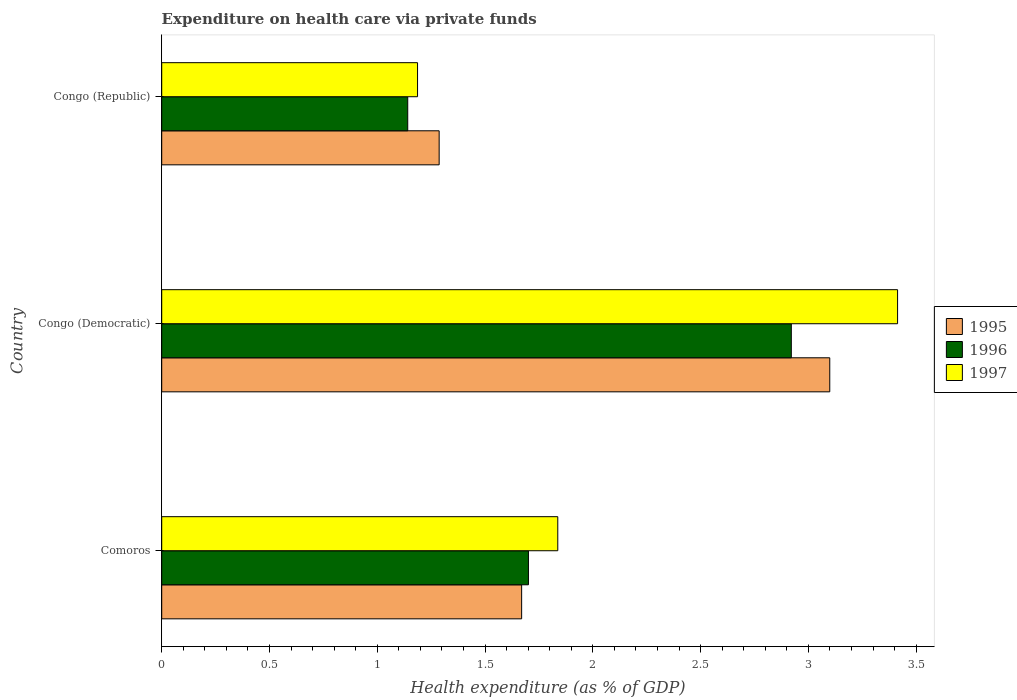How many different coloured bars are there?
Offer a very short reply. 3. How many groups of bars are there?
Offer a terse response. 3. How many bars are there on the 1st tick from the top?
Ensure brevity in your answer.  3. What is the label of the 1st group of bars from the top?
Your response must be concise. Congo (Republic). What is the expenditure made on health care in 1996 in Comoros?
Your response must be concise. 1.7. Across all countries, what is the maximum expenditure made on health care in 1996?
Your answer should be very brief. 2.92. Across all countries, what is the minimum expenditure made on health care in 1997?
Your answer should be very brief. 1.19. In which country was the expenditure made on health care in 1997 maximum?
Provide a succinct answer. Congo (Democratic). In which country was the expenditure made on health care in 1997 minimum?
Give a very brief answer. Congo (Republic). What is the total expenditure made on health care in 1997 in the graph?
Provide a succinct answer. 6.44. What is the difference between the expenditure made on health care in 1997 in Comoros and that in Congo (Republic)?
Make the answer very short. 0.65. What is the difference between the expenditure made on health care in 1995 in Comoros and the expenditure made on health care in 1996 in Congo (Republic)?
Your answer should be compact. 0.53. What is the average expenditure made on health care in 1996 per country?
Your answer should be compact. 1.92. What is the difference between the expenditure made on health care in 1997 and expenditure made on health care in 1996 in Congo (Democratic)?
Your response must be concise. 0.49. What is the ratio of the expenditure made on health care in 1996 in Comoros to that in Congo (Republic)?
Make the answer very short. 1.49. Is the expenditure made on health care in 1996 in Comoros less than that in Congo (Republic)?
Give a very brief answer. No. Is the difference between the expenditure made on health care in 1997 in Comoros and Congo (Republic) greater than the difference between the expenditure made on health care in 1996 in Comoros and Congo (Republic)?
Provide a succinct answer. Yes. What is the difference between the highest and the second highest expenditure made on health care in 1996?
Ensure brevity in your answer.  1.22. What is the difference between the highest and the lowest expenditure made on health care in 1997?
Your answer should be compact. 2.23. Is the sum of the expenditure made on health care in 1995 in Comoros and Congo (Republic) greater than the maximum expenditure made on health care in 1997 across all countries?
Your answer should be compact. No. What does the 2nd bar from the top in Congo (Democratic) represents?
Provide a succinct answer. 1996. How many bars are there?
Keep it short and to the point. 9. Are all the bars in the graph horizontal?
Ensure brevity in your answer.  Yes. How many countries are there in the graph?
Your response must be concise. 3. Are the values on the major ticks of X-axis written in scientific E-notation?
Provide a short and direct response. No. Does the graph contain grids?
Keep it short and to the point. No. How many legend labels are there?
Provide a short and direct response. 3. How are the legend labels stacked?
Your answer should be compact. Vertical. What is the title of the graph?
Give a very brief answer. Expenditure on health care via private funds. Does "1968" appear as one of the legend labels in the graph?
Offer a terse response. No. What is the label or title of the X-axis?
Offer a terse response. Health expenditure (as % of GDP). What is the Health expenditure (as % of GDP) in 1995 in Comoros?
Keep it short and to the point. 1.67. What is the Health expenditure (as % of GDP) in 1996 in Comoros?
Offer a terse response. 1.7. What is the Health expenditure (as % of GDP) in 1997 in Comoros?
Your answer should be very brief. 1.84. What is the Health expenditure (as % of GDP) in 1995 in Congo (Democratic)?
Offer a terse response. 3.1. What is the Health expenditure (as % of GDP) in 1996 in Congo (Democratic)?
Keep it short and to the point. 2.92. What is the Health expenditure (as % of GDP) of 1997 in Congo (Democratic)?
Your answer should be very brief. 3.41. What is the Health expenditure (as % of GDP) of 1995 in Congo (Republic)?
Provide a succinct answer. 1.29. What is the Health expenditure (as % of GDP) in 1996 in Congo (Republic)?
Offer a very short reply. 1.14. What is the Health expenditure (as % of GDP) of 1997 in Congo (Republic)?
Make the answer very short. 1.19. Across all countries, what is the maximum Health expenditure (as % of GDP) of 1995?
Offer a very short reply. 3.1. Across all countries, what is the maximum Health expenditure (as % of GDP) in 1996?
Your answer should be very brief. 2.92. Across all countries, what is the maximum Health expenditure (as % of GDP) in 1997?
Your response must be concise. 3.41. Across all countries, what is the minimum Health expenditure (as % of GDP) in 1995?
Provide a short and direct response. 1.29. Across all countries, what is the minimum Health expenditure (as % of GDP) of 1996?
Offer a terse response. 1.14. Across all countries, what is the minimum Health expenditure (as % of GDP) in 1997?
Your answer should be very brief. 1.19. What is the total Health expenditure (as % of GDP) of 1995 in the graph?
Ensure brevity in your answer.  6.06. What is the total Health expenditure (as % of GDP) of 1996 in the graph?
Your response must be concise. 5.76. What is the total Health expenditure (as % of GDP) of 1997 in the graph?
Your answer should be compact. 6.44. What is the difference between the Health expenditure (as % of GDP) of 1995 in Comoros and that in Congo (Democratic)?
Offer a terse response. -1.43. What is the difference between the Health expenditure (as % of GDP) in 1996 in Comoros and that in Congo (Democratic)?
Keep it short and to the point. -1.22. What is the difference between the Health expenditure (as % of GDP) in 1997 in Comoros and that in Congo (Democratic)?
Keep it short and to the point. -1.58. What is the difference between the Health expenditure (as % of GDP) of 1995 in Comoros and that in Congo (Republic)?
Provide a succinct answer. 0.38. What is the difference between the Health expenditure (as % of GDP) in 1996 in Comoros and that in Congo (Republic)?
Your response must be concise. 0.56. What is the difference between the Health expenditure (as % of GDP) in 1997 in Comoros and that in Congo (Republic)?
Provide a succinct answer. 0.65. What is the difference between the Health expenditure (as % of GDP) in 1995 in Congo (Democratic) and that in Congo (Republic)?
Your answer should be compact. 1.81. What is the difference between the Health expenditure (as % of GDP) of 1996 in Congo (Democratic) and that in Congo (Republic)?
Your response must be concise. 1.78. What is the difference between the Health expenditure (as % of GDP) in 1997 in Congo (Democratic) and that in Congo (Republic)?
Make the answer very short. 2.23. What is the difference between the Health expenditure (as % of GDP) of 1995 in Comoros and the Health expenditure (as % of GDP) of 1996 in Congo (Democratic)?
Keep it short and to the point. -1.25. What is the difference between the Health expenditure (as % of GDP) in 1995 in Comoros and the Health expenditure (as % of GDP) in 1997 in Congo (Democratic)?
Your answer should be very brief. -1.74. What is the difference between the Health expenditure (as % of GDP) of 1996 in Comoros and the Health expenditure (as % of GDP) of 1997 in Congo (Democratic)?
Offer a terse response. -1.71. What is the difference between the Health expenditure (as % of GDP) in 1995 in Comoros and the Health expenditure (as % of GDP) in 1996 in Congo (Republic)?
Your answer should be compact. 0.53. What is the difference between the Health expenditure (as % of GDP) in 1995 in Comoros and the Health expenditure (as % of GDP) in 1997 in Congo (Republic)?
Make the answer very short. 0.48. What is the difference between the Health expenditure (as % of GDP) of 1996 in Comoros and the Health expenditure (as % of GDP) of 1997 in Congo (Republic)?
Make the answer very short. 0.51. What is the difference between the Health expenditure (as % of GDP) in 1995 in Congo (Democratic) and the Health expenditure (as % of GDP) in 1996 in Congo (Republic)?
Keep it short and to the point. 1.96. What is the difference between the Health expenditure (as % of GDP) of 1995 in Congo (Democratic) and the Health expenditure (as % of GDP) of 1997 in Congo (Republic)?
Give a very brief answer. 1.91. What is the difference between the Health expenditure (as % of GDP) in 1996 in Congo (Democratic) and the Health expenditure (as % of GDP) in 1997 in Congo (Republic)?
Your answer should be very brief. 1.73. What is the average Health expenditure (as % of GDP) in 1995 per country?
Offer a very short reply. 2.02. What is the average Health expenditure (as % of GDP) in 1996 per country?
Ensure brevity in your answer.  1.92. What is the average Health expenditure (as % of GDP) in 1997 per country?
Provide a succinct answer. 2.15. What is the difference between the Health expenditure (as % of GDP) of 1995 and Health expenditure (as % of GDP) of 1996 in Comoros?
Make the answer very short. -0.03. What is the difference between the Health expenditure (as % of GDP) of 1995 and Health expenditure (as % of GDP) of 1997 in Comoros?
Your response must be concise. -0.17. What is the difference between the Health expenditure (as % of GDP) of 1996 and Health expenditure (as % of GDP) of 1997 in Comoros?
Provide a short and direct response. -0.14. What is the difference between the Health expenditure (as % of GDP) of 1995 and Health expenditure (as % of GDP) of 1996 in Congo (Democratic)?
Keep it short and to the point. 0.18. What is the difference between the Health expenditure (as % of GDP) in 1995 and Health expenditure (as % of GDP) in 1997 in Congo (Democratic)?
Your answer should be very brief. -0.31. What is the difference between the Health expenditure (as % of GDP) of 1996 and Health expenditure (as % of GDP) of 1997 in Congo (Democratic)?
Your answer should be very brief. -0.49. What is the difference between the Health expenditure (as % of GDP) in 1995 and Health expenditure (as % of GDP) in 1996 in Congo (Republic)?
Your answer should be very brief. 0.15. What is the difference between the Health expenditure (as % of GDP) of 1995 and Health expenditure (as % of GDP) of 1997 in Congo (Republic)?
Provide a succinct answer. 0.1. What is the difference between the Health expenditure (as % of GDP) in 1996 and Health expenditure (as % of GDP) in 1997 in Congo (Republic)?
Provide a succinct answer. -0.05. What is the ratio of the Health expenditure (as % of GDP) of 1995 in Comoros to that in Congo (Democratic)?
Ensure brevity in your answer.  0.54. What is the ratio of the Health expenditure (as % of GDP) of 1996 in Comoros to that in Congo (Democratic)?
Offer a very short reply. 0.58. What is the ratio of the Health expenditure (as % of GDP) in 1997 in Comoros to that in Congo (Democratic)?
Keep it short and to the point. 0.54. What is the ratio of the Health expenditure (as % of GDP) in 1995 in Comoros to that in Congo (Republic)?
Provide a succinct answer. 1.3. What is the ratio of the Health expenditure (as % of GDP) in 1996 in Comoros to that in Congo (Republic)?
Provide a succinct answer. 1.49. What is the ratio of the Health expenditure (as % of GDP) in 1997 in Comoros to that in Congo (Republic)?
Your answer should be compact. 1.55. What is the ratio of the Health expenditure (as % of GDP) of 1995 in Congo (Democratic) to that in Congo (Republic)?
Offer a very short reply. 2.41. What is the ratio of the Health expenditure (as % of GDP) of 1996 in Congo (Democratic) to that in Congo (Republic)?
Keep it short and to the point. 2.56. What is the ratio of the Health expenditure (as % of GDP) of 1997 in Congo (Democratic) to that in Congo (Republic)?
Your answer should be very brief. 2.88. What is the difference between the highest and the second highest Health expenditure (as % of GDP) in 1995?
Ensure brevity in your answer.  1.43. What is the difference between the highest and the second highest Health expenditure (as % of GDP) of 1996?
Give a very brief answer. 1.22. What is the difference between the highest and the second highest Health expenditure (as % of GDP) of 1997?
Give a very brief answer. 1.58. What is the difference between the highest and the lowest Health expenditure (as % of GDP) of 1995?
Your answer should be very brief. 1.81. What is the difference between the highest and the lowest Health expenditure (as % of GDP) in 1996?
Keep it short and to the point. 1.78. What is the difference between the highest and the lowest Health expenditure (as % of GDP) in 1997?
Your answer should be very brief. 2.23. 